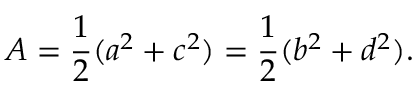Convert formula to latex. <formula><loc_0><loc_0><loc_500><loc_500>A = { \frac { 1 } { 2 } } ( a ^ { 2 } + c ^ { 2 } ) = { \frac { 1 } { 2 } } ( b ^ { 2 } + d ^ { 2 } ) .</formula> 